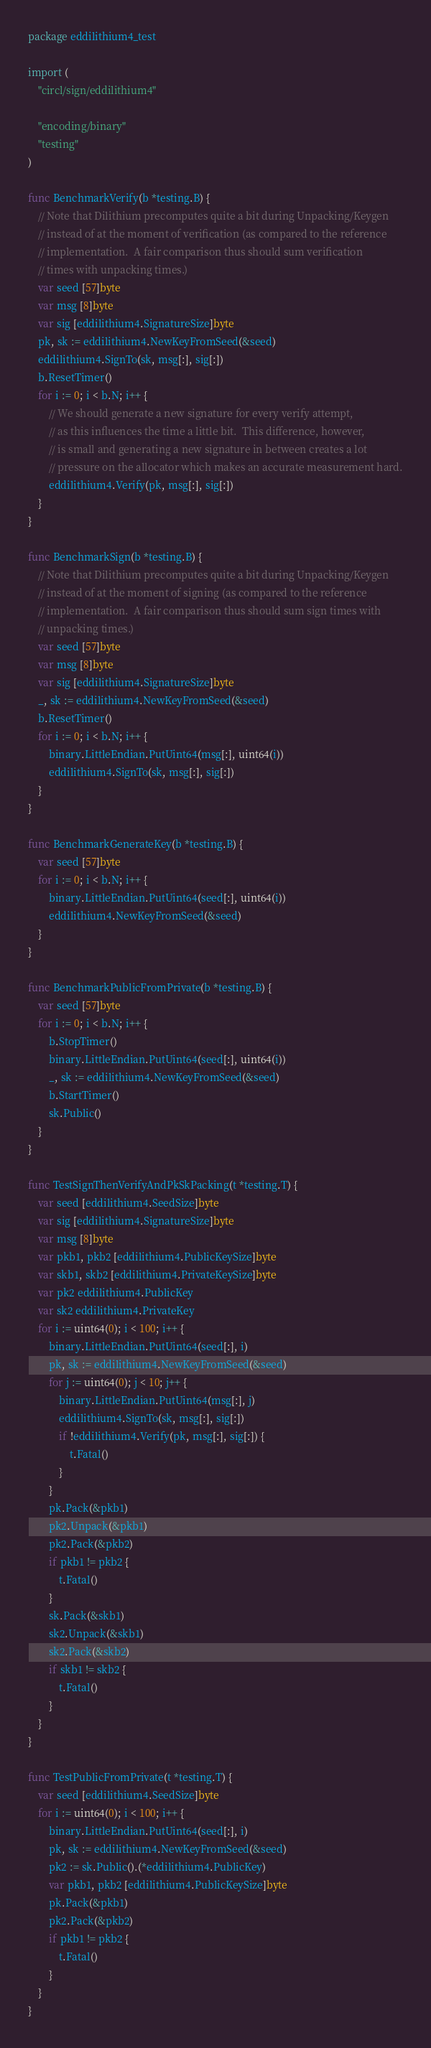Convert code to text. <code><loc_0><loc_0><loc_500><loc_500><_Go_>package eddilithium4_test

import (
	"circl/sign/eddilithium4"

	"encoding/binary"
	"testing"
)

func BenchmarkVerify(b *testing.B) {
	// Note that Dilithium precomputes quite a bit during Unpacking/Keygen
	// instead of at the moment of verification (as compared to the reference
	// implementation.  A fair comparison thus should sum verification
	// times with unpacking times.)
	var seed [57]byte
	var msg [8]byte
	var sig [eddilithium4.SignatureSize]byte
	pk, sk := eddilithium4.NewKeyFromSeed(&seed)
	eddilithium4.SignTo(sk, msg[:], sig[:])
	b.ResetTimer()
	for i := 0; i < b.N; i++ {
		// We should generate a new signature for every verify attempt,
		// as this influences the time a little bit.  This difference, however,
		// is small and generating a new signature in between creates a lot
		// pressure on the allocator which makes an accurate measurement hard.
		eddilithium4.Verify(pk, msg[:], sig[:])
	}
}

func BenchmarkSign(b *testing.B) {
	// Note that Dilithium precomputes quite a bit during Unpacking/Keygen
	// instead of at the moment of signing (as compared to the reference
	// implementation.  A fair comparison thus should sum sign times with
	// unpacking times.)
	var seed [57]byte
	var msg [8]byte
	var sig [eddilithium4.SignatureSize]byte
	_, sk := eddilithium4.NewKeyFromSeed(&seed)
	b.ResetTimer()
	for i := 0; i < b.N; i++ {
		binary.LittleEndian.PutUint64(msg[:], uint64(i))
		eddilithium4.SignTo(sk, msg[:], sig[:])
	}
}

func BenchmarkGenerateKey(b *testing.B) {
	var seed [57]byte
	for i := 0; i < b.N; i++ {
		binary.LittleEndian.PutUint64(seed[:], uint64(i))
		eddilithium4.NewKeyFromSeed(&seed)
	}
}

func BenchmarkPublicFromPrivate(b *testing.B) {
	var seed [57]byte
	for i := 0; i < b.N; i++ {
		b.StopTimer()
		binary.LittleEndian.PutUint64(seed[:], uint64(i))
		_, sk := eddilithium4.NewKeyFromSeed(&seed)
		b.StartTimer()
		sk.Public()
	}
}

func TestSignThenVerifyAndPkSkPacking(t *testing.T) {
	var seed [eddilithium4.SeedSize]byte
	var sig [eddilithium4.SignatureSize]byte
	var msg [8]byte
	var pkb1, pkb2 [eddilithium4.PublicKeySize]byte
	var skb1, skb2 [eddilithium4.PrivateKeySize]byte
	var pk2 eddilithium4.PublicKey
	var sk2 eddilithium4.PrivateKey
	for i := uint64(0); i < 100; i++ {
		binary.LittleEndian.PutUint64(seed[:], i)
		pk, sk := eddilithium4.NewKeyFromSeed(&seed)
		for j := uint64(0); j < 10; j++ {
			binary.LittleEndian.PutUint64(msg[:], j)
			eddilithium4.SignTo(sk, msg[:], sig[:])
			if !eddilithium4.Verify(pk, msg[:], sig[:]) {
				t.Fatal()
			}
		}
		pk.Pack(&pkb1)
		pk2.Unpack(&pkb1)
		pk2.Pack(&pkb2)
		if pkb1 != pkb2 {
			t.Fatal()
		}
		sk.Pack(&skb1)
		sk2.Unpack(&skb1)
		sk2.Pack(&skb2)
		if skb1 != skb2 {
			t.Fatal()
		}
	}
}

func TestPublicFromPrivate(t *testing.T) {
	var seed [eddilithium4.SeedSize]byte
	for i := uint64(0); i < 100; i++ {
		binary.LittleEndian.PutUint64(seed[:], i)
		pk, sk := eddilithium4.NewKeyFromSeed(&seed)
		pk2 := sk.Public().(*eddilithium4.PublicKey)
		var pkb1, pkb2 [eddilithium4.PublicKeySize]byte
		pk.Pack(&pkb1)
		pk2.Pack(&pkb2)
		if pkb1 != pkb2 {
			t.Fatal()
		}
	}
}
</code> 